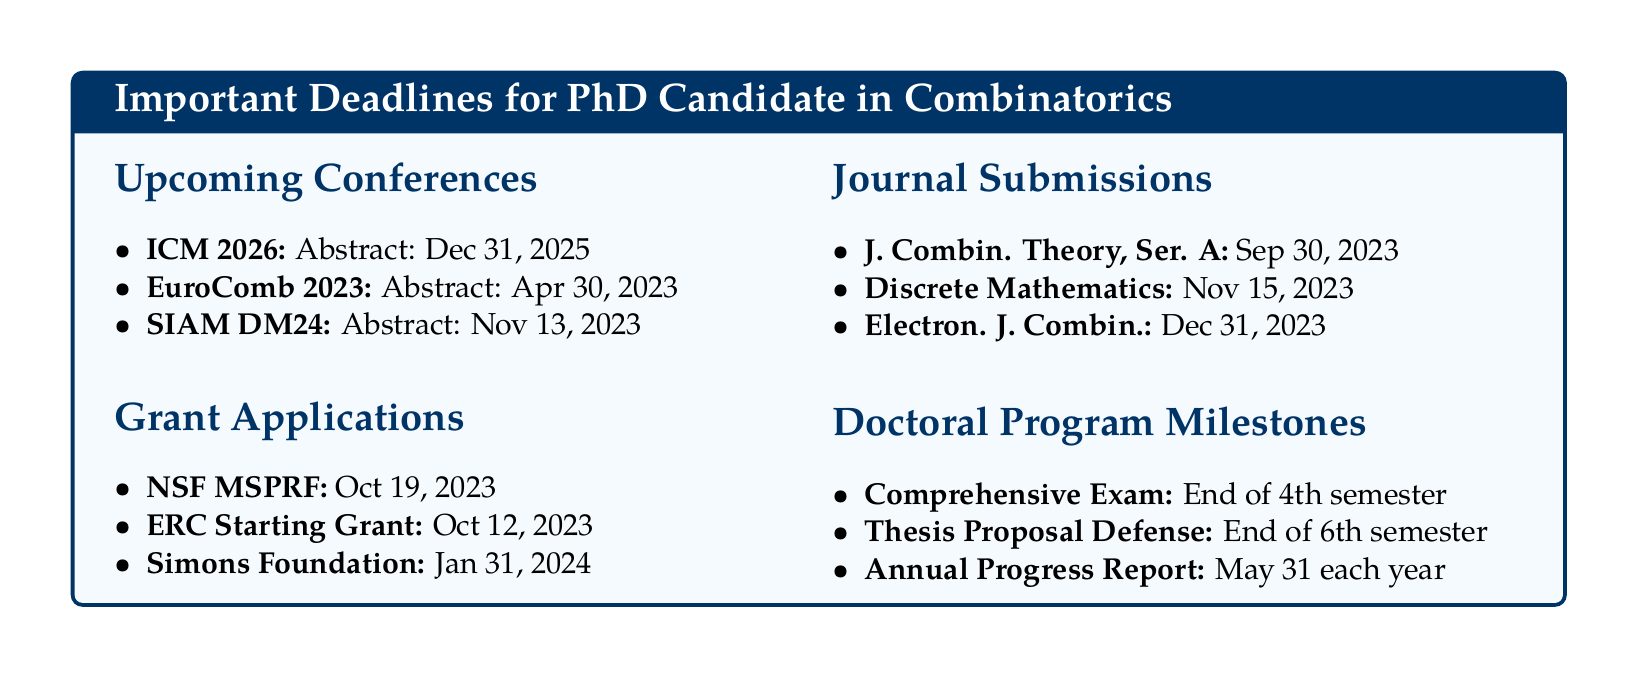what is the abstract deadline for ICM 2026? The abstract deadline for ICM 2026 is specified as December 31, 2025 in the document.
Answer: December 31, 2025 when is the registration deadline for SIAM DM24? The registration deadline for SIAM DM24 is listed as May 13, 2024 in the document.
Answer: May 13, 2024 how much is the award amount for the NSF MSPRF grant? The award amount for the NSF MSPRF grant is stated as $150,000 over two years in the document.
Answer: $150,000 which journal has a submission deadline of November 15, 2023? The journal with a submission deadline of November 15, 2023 is Discrete Mathematics, according to the document.
Answer: Discrete Mathematics what is the expected publication date for the special issue of the Journal of Combinatorial Theory, Series A? The expected publication date for the special issue is mentioned as May 2024 in the document.
Answer: May 2024 what is the event associated with the deadline of the end of the 4th semester? The event associated with this deadline is the Comprehensive Exam as noted in the document.
Answer: Comprehensive Exam how many years of experience is required for the ERC Starting Grant eligibility? The eligibility requires 2-7 years of experience since completion of PhD as per the document's details.
Answer: 2-7 years which grant application has the earliest deadline? The earliest deadline for a grant application is October 12, 2023 for the ERC Starting Grant according to the document.
Answer: October 12, 2023 what is the focus of the next special issue for Electronic Journal of Combinatorics? The focus is on Enumerative Combinatorics as indicated in the document.
Answer: Enumerative Combinatorics 